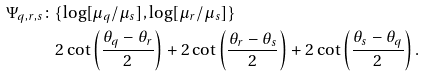Convert formula to latex. <formula><loc_0><loc_0><loc_500><loc_500>\Psi _ { q , r , s } \colon & \{ \log [ \mu _ { q } / \mu _ { s } ] , \log [ \mu _ { r } / \mu _ { s } ] \} \\ & 2 \cot \left ( \frac { \theta _ { q } - \theta _ { r } } 2 \right ) + 2 \cot \left ( \frac { \theta _ { r } - \theta _ { s } } 2 \right ) + 2 \cot \left ( \frac { \theta _ { s } - \theta _ { q } } 2 \right ) .</formula> 